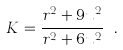Convert formula to latex. <formula><loc_0><loc_0><loc_500><loc_500>K = \frac { r ^ { 2 } + 9 u ^ { 2 } } { r ^ { 2 } + 6 u ^ { 2 } } \ .</formula> 